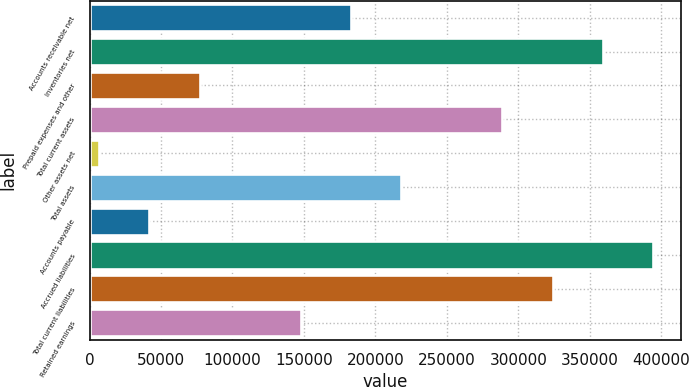Convert chart. <chart><loc_0><loc_0><loc_500><loc_500><bar_chart><fcel>Accounts receivable net<fcel>Inventories net<fcel>Prepaid expenses and other<fcel>Total current assets<fcel>Other assets net<fcel>Total assets<fcel>Accounts payable<fcel>Accrued liabilities<fcel>Total current liabilities<fcel>Retained earnings<nl><fcel>182885<fcel>359099<fcel>77156.6<fcel>288613<fcel>6671<fcel>218128<fcel>41913.8<fcel>394342<fcel>323856<fcel>147642<nl></chart> 